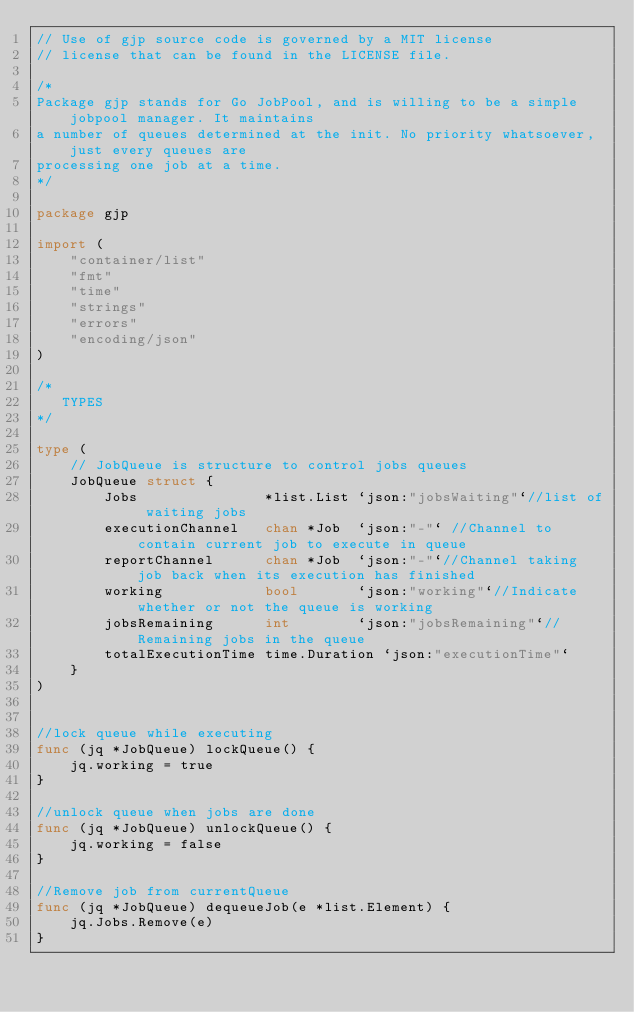<code> <loc_0><loc_0><loc_500><loc_500><_Go_>// Use of gjp source code is governed by a MIT license
// license that can be found in the LICENSE file.

/*
Package gjp stands for Go JobPool, and is willing to be a simple jobpool manager. It maintains
a number of queues determined at the init. No priority whatsoever, just every queues are
processing one job at a time.
*/

package gjp

import (
	"container/list"
	"fmt"
	"time"
	"strings"
	"errors"
	"encoding/json"
)

/*
   TYPES
*/

type (
	// JobQueue is structure to control jobs queues
	JobQueue struct {
		Jobs               *list.List `json:"jobsWaiting"`//list of waiting jobs
		executionChannel   chan *Job  `json:"-"` //Channel to contain current job to execute in queue
		reportChannel      chan *Job  `json:"-"`//Channel taking job back when its execution has finished
		working            bool       `json:"working"`//Indicate whether or not the queue is working
		jobsRemaining      int        `json:"jobsRemaining"`//Remaining jobs in the queue
		totalExecutionTime time.Duration `json:"executionTime"`
	}
)


//lock queue while executing
func (jq *JobQueue) lockQueue() {
	jq.working = true
}

//unlock queue when jobs are done
func (jq *JobQueue) unlockQueue() {
	jq.working = false
}

//Remove job from currentQueue
func (jq *JobQueue) dequeueJob(e *list.Element) {
	jq.Jobs.Remove(e)
}
</code> 